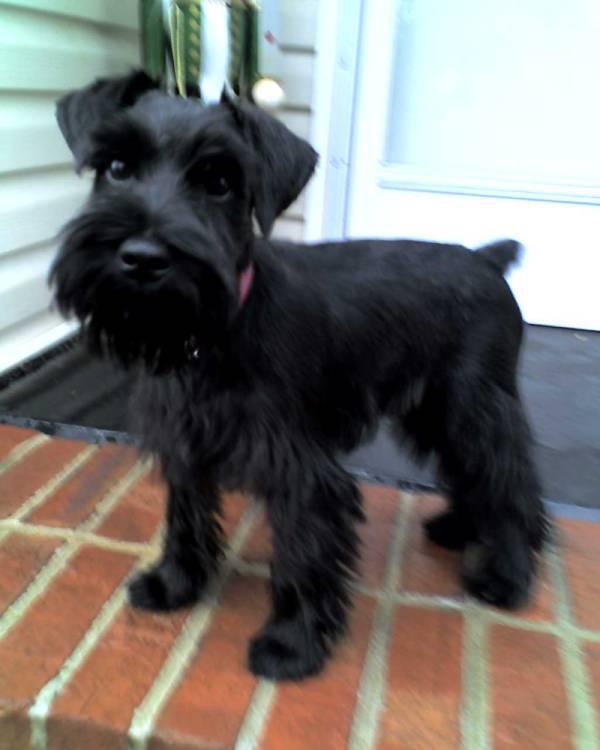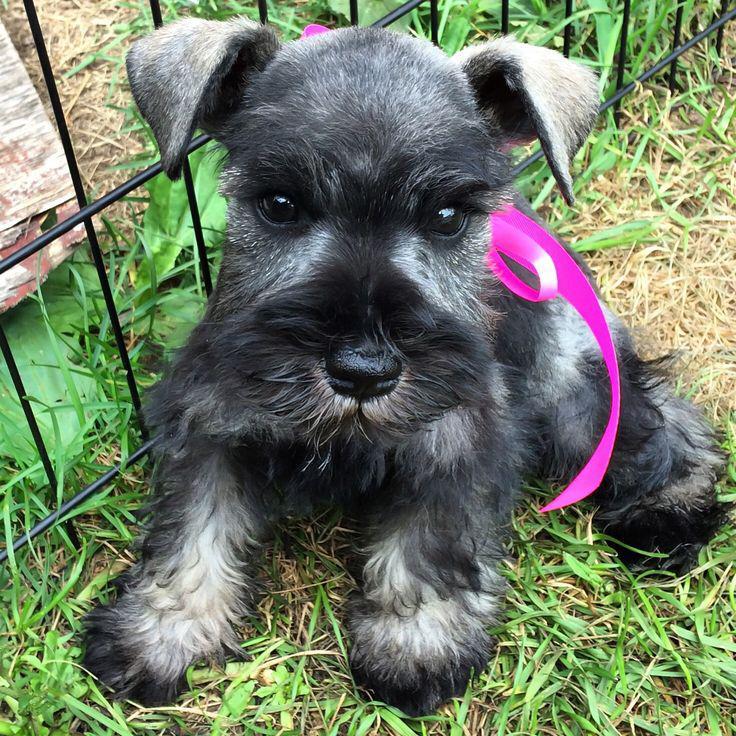The first image is the image on the left, the second image is the image on the right. Examine the images to the left and right. Is the description "Each image shows a leash extending from the left to a standing schnauzer dog." accurate? Answer yes or no. No. The first image is the image on the left, the second image is the image on the right. For the images shown, is this caption "Both dogs are attached to a leash." true? Answer yes or no. No. 